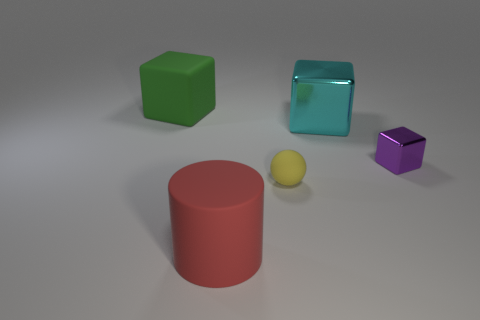Subtract all blue balls. Subtract all purple cylinders. How many balls are left? 1 Subtract all gray spheres. How many purple blocks are left? 1 Add 3 tiny cyans. How many small yellows exist? 0 Subtract all large blocks. Subtract all tiny gray metal balls. How many objects are left? 3 Add 5 big cylinders. How many big cylinders are left? 6 Add 2 big red things. How many big red things exist? 3 Add 2 rubber blocks. How many objects exist? 7 Subtract all purple cubes. How many cubes are left? 2 Subtract all small purple metal blocks. How many blocks are left? 2 Subtract 0 cyan cylinders. How many objects are left? 5 